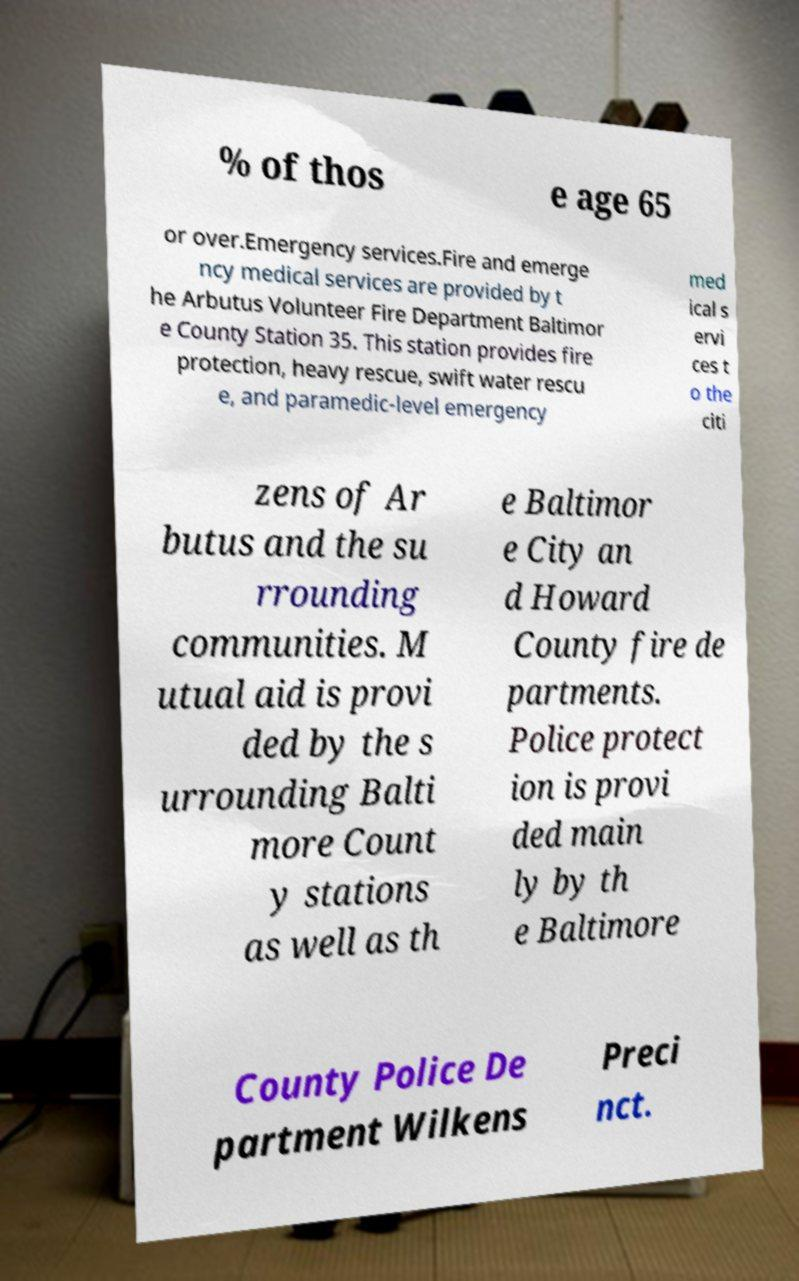For documentation purposes, I need the text within this image transcribed. Could you provide that? % of thos e age 65 or over.Emergency services.Fire and emerge ncy medical services are provided by t he Arbutus Volunteer Fire Department Baltimor e County Station 35. This station provides fire protection, heavy rescue, swift water rescu e, and paramedic-level emergency med ical s ervi ces t o the citi zens of Ar butus and the su rrounding communities. M utual aid is provi ded by the s urrounding Balti more Count y stations as well as th e Baltimor e City an d Howard County fire de partments. Police protect ion is provi ded main ly by th e Baltimore County Police De partment Wilkens Preci nct. 